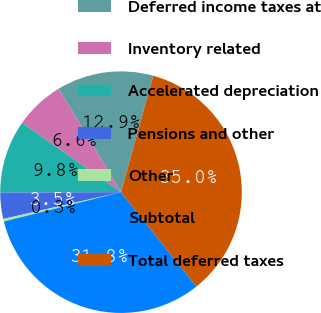Convert chart to OTSL. <chart><loc_0><loc_0><loc_500><loc_500><pie_chart><fcel>Deferred income taxes at<fcel>Inventory related<fcel>Accelerated depreciation<fcel>Pensions and other<fcel>Other<fcel>Subtotal<fcel>Total deferred taxes<nl><fcel>12.94%<fcel>6.64%<fcel>9.79%<fcel>3.5%<fcel>0.35%<fcel>31.82%<fcel>34.97%<nl></chart> 